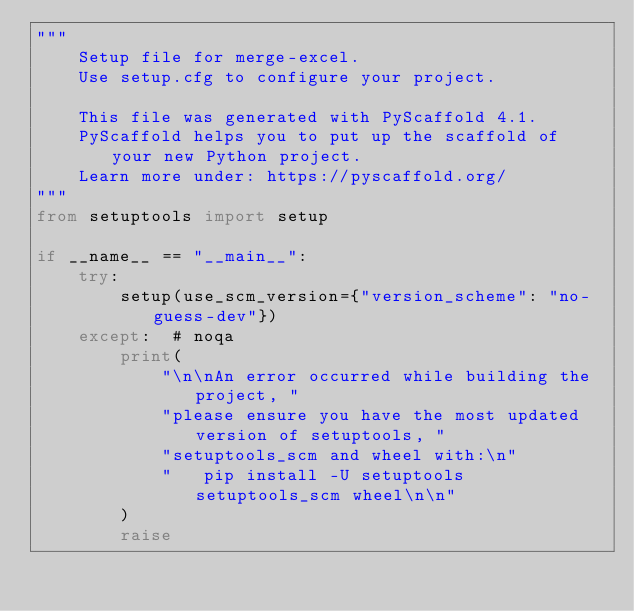Convert code to text. <code><loc_0><loc_0><loc_500><loc_500><_Python_>"""
    Setup file for merge-excel.
    Use setup.cfg to configure your project.

    This file was generated with PyScaffold 4.1.
    PyScaffold helps you to put up the scaffold of your new Python project.
    Learn more under: https://pyscaffold.org/
"""
from setuptools import setup

if __name__ == "__main__":
    try:
        setup(use_scm_version={"version_scheme": "no-guess-dev"})
    except:  # noqa
        print(
            "\n\nAn error occurred while building the project, "
            "please ensure you have the most updated version of setuptools, "
            "setuptools_scm and wheel with:\n"
            "   pip install -U setuptools setuptools_scm wheel\n\n"
        )
        raise
</code> 